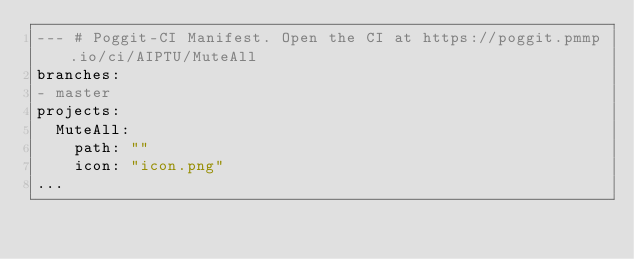<code> <loc_0><loc_0><loc_500><loc_500><_YAML_>--- # Poggit-CI Manifest. Open the CI at https://poggit.pmmp.io/ci/AIPTU/MuteAll
branches:
- master
projects:
  MuteAll:
    path: ""
    icon: "icon.png"
...
</code> 